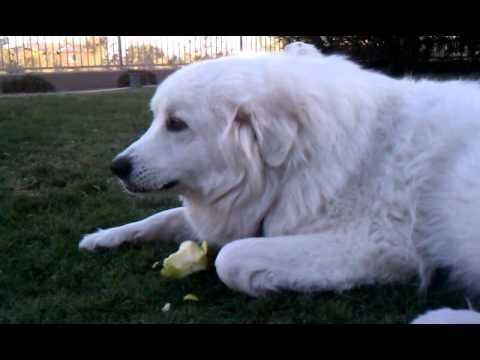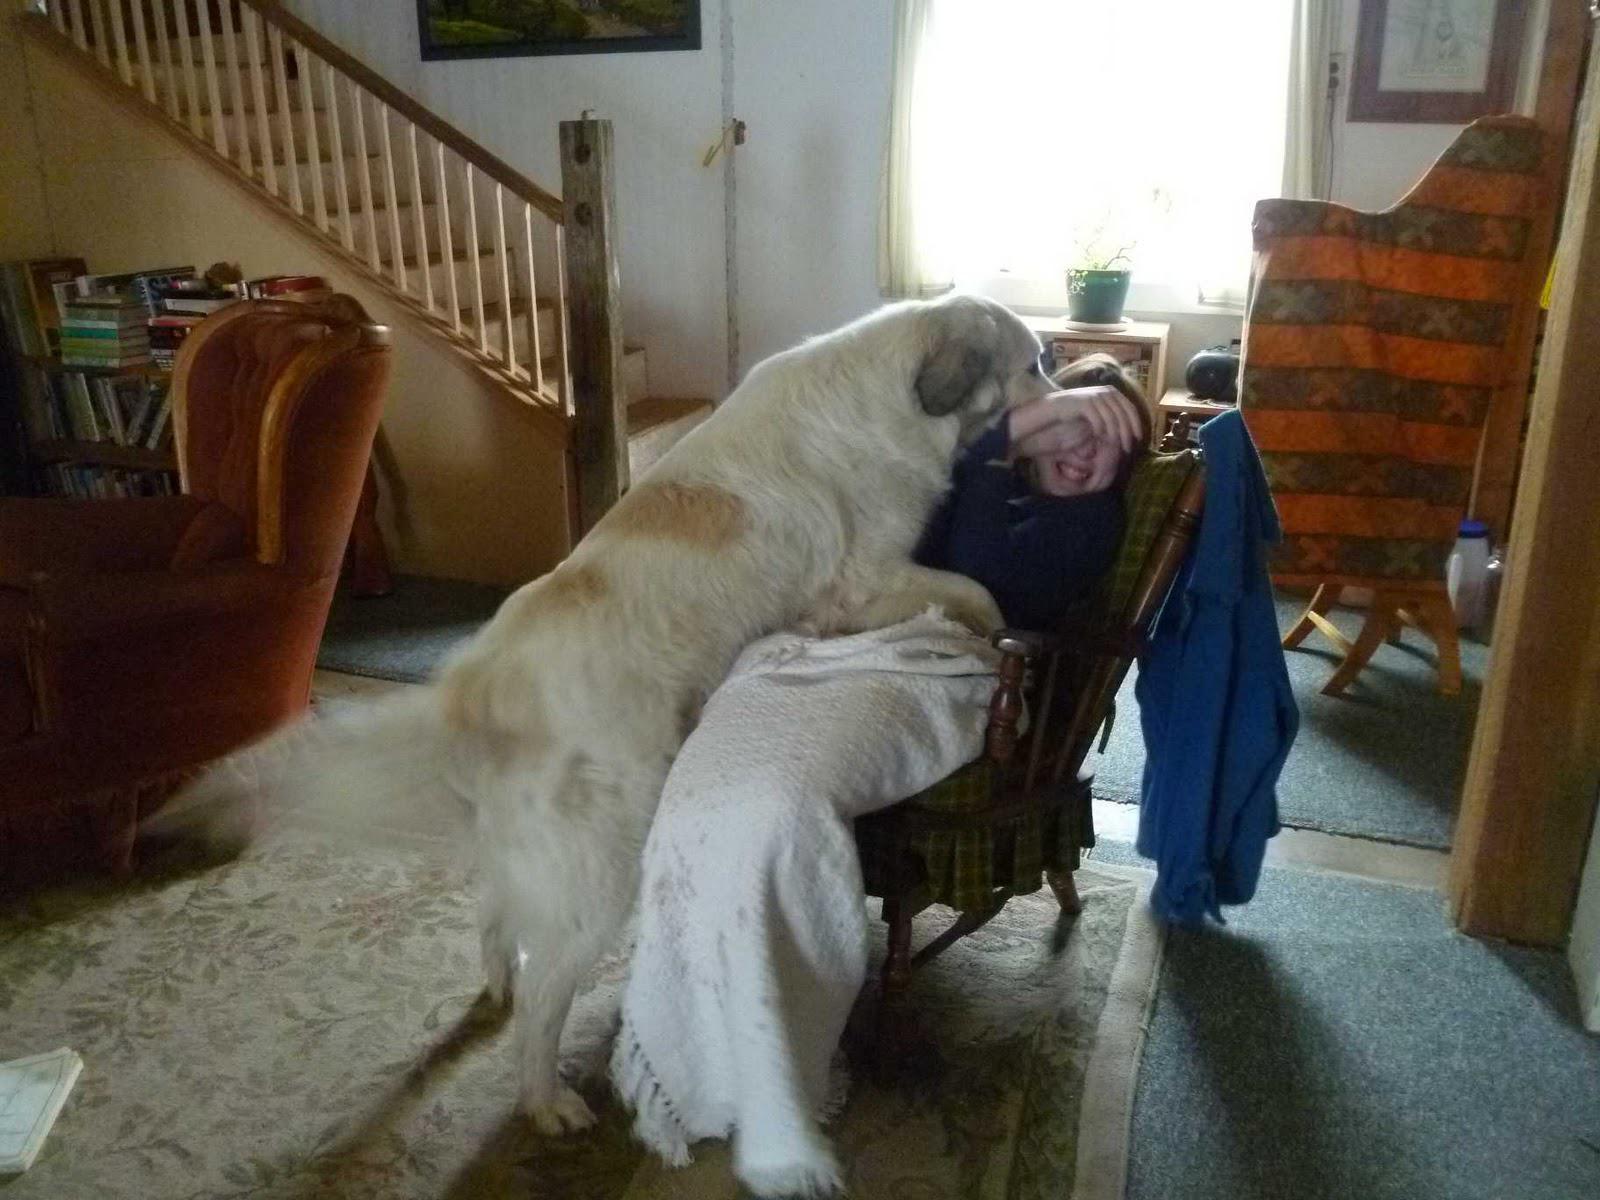The first image is the image on the left, the second image is the image on the right. Considering the images on both sides, is "An image shows a dog standing in front of a chair with only his hind legs on the floor." valid? Answer yes or no. Yes. The first image is the image on the left, the second image is the image on the right. For the images displayed, is the sentence "At least four dogs are eating from bowls in the image on the left." factually correct? Answer yes or no. No. 